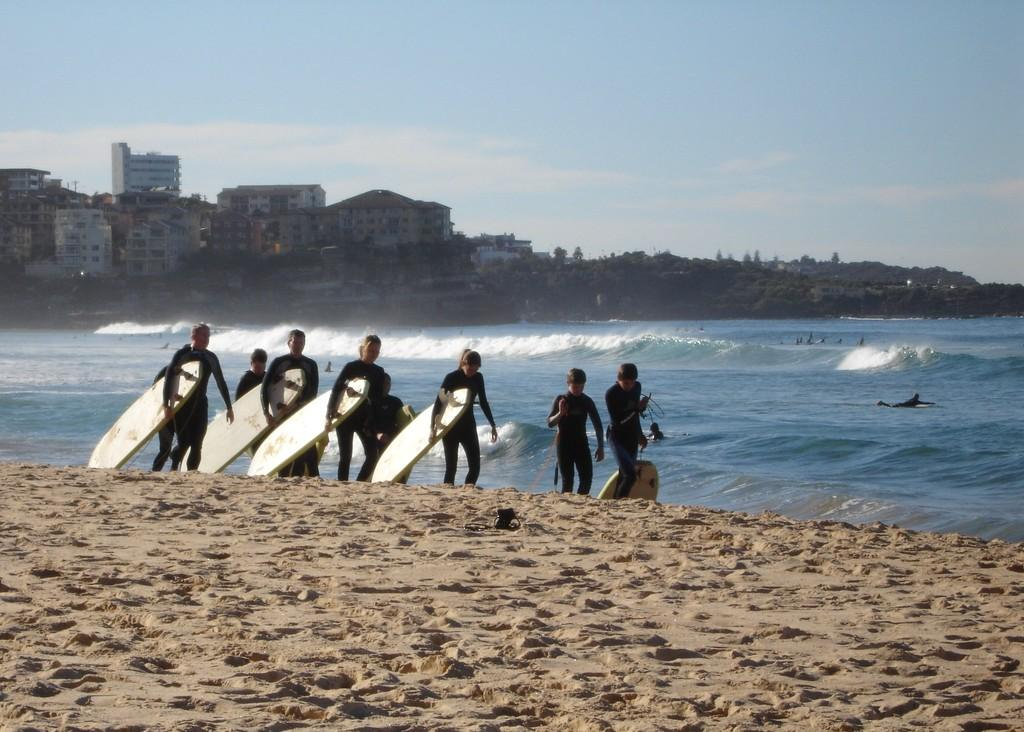What is happening in the image? There is a person in the image who is catching a sky board. What can be seen in the background of the image? There is water, a tree, a building, and the sky visible in the background. What is the person doing with the sky board? The person is catching the sky board. How many toes can be seen on the person's feet in the image? The image does not show the person's feet, so the number of toes cannot be determined. 